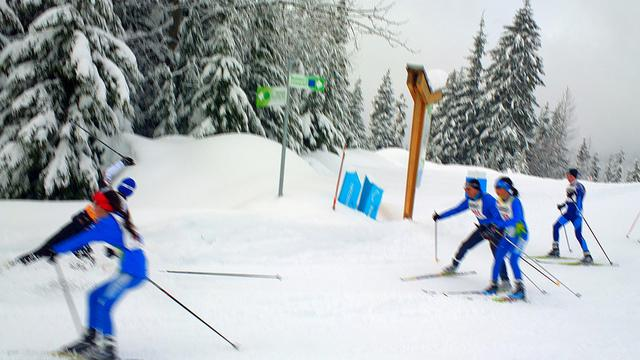What are these people doing with each other?

Choices:
A) resting
B) singing
C) yelling
D) racing racing 